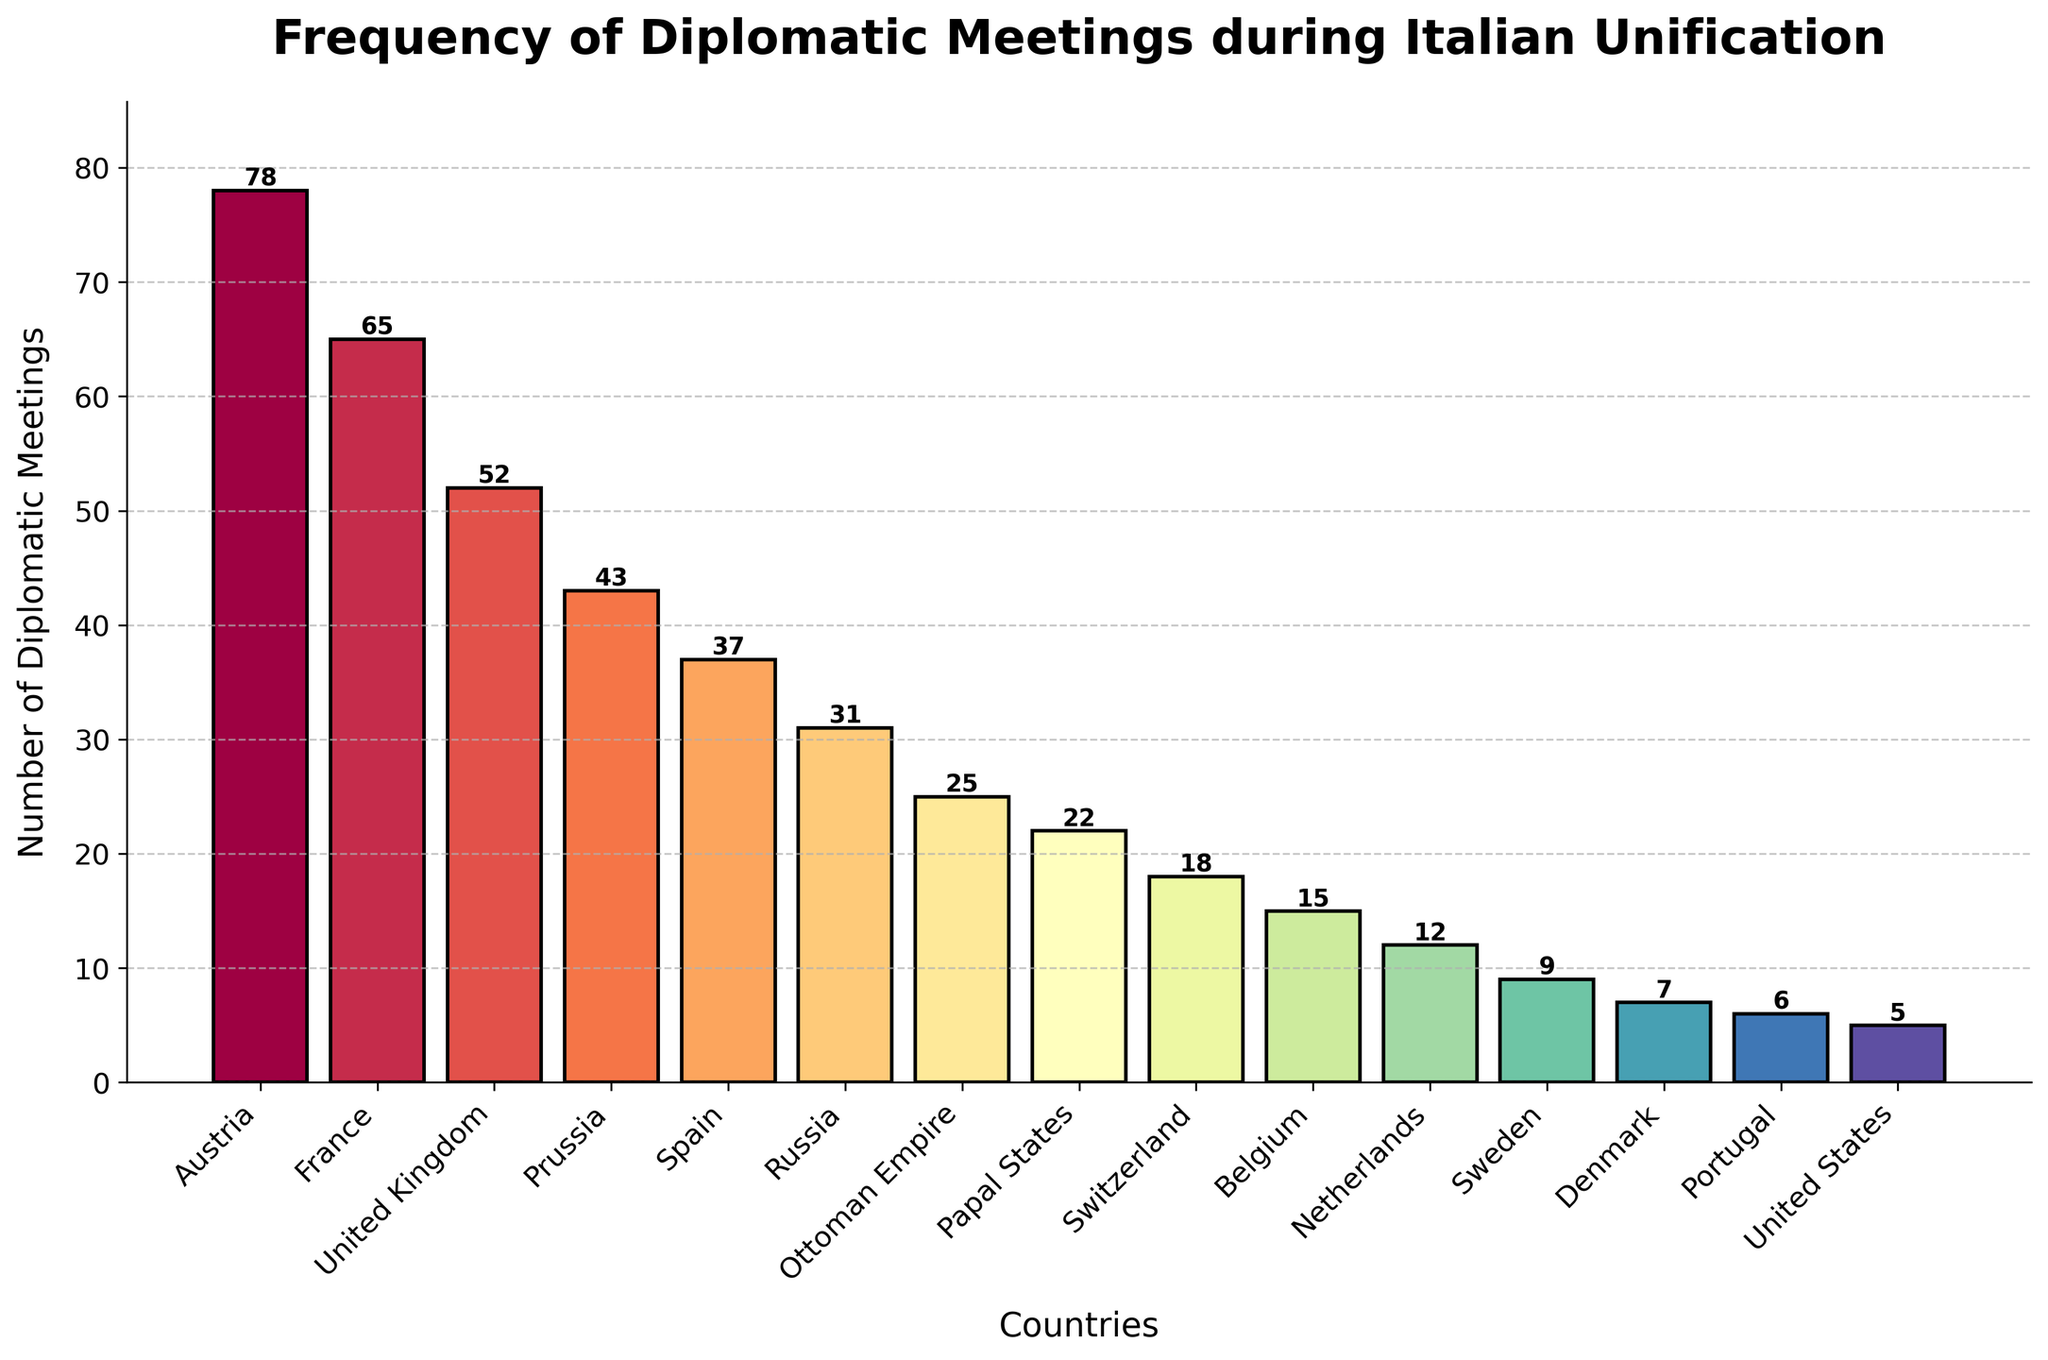Which country had the highest number of diplomatic meetings during the Italian unification? The bar for Austria is the tallest in the figure, indicating it had the highest number of meetings.
Answer: Austria Which country had the fewest diplomatic meetings? The bar for the United States is the shortest in the figure, indicating it had the fewest meetings.
Answer: United States How many more diplomatic meetings did Austria have compared to Prussia? Austria had 78 meetings and Prussia had 43; the difference is calculated as 78 - 43.
Answer: 35 What is the total number of diplomatic meetings with France, United Kingdom, and Prussia combined? Sum the number of meetings for France (65), United Kingdom (52), and Prussia (43). 65 + 52 + 43 = 160.
Answer: 160 Is the number of meetings with Spain greater than with Russia? Compare the heights of the Spain and Russia bars. Spain has 37 meetings and Russia has 31.
Answer: Yes How many more diplomatic meetings did the Papal States have compared to Denmark and the Netherlands combined? Papal States had 22 meetings. Denmark and Netherlands combined had 7 + 12 = 19 meetings. The difference is 22 - 19.
Answer: 3 Which country had a color bar most similar to the Papal States in the gradient spectrum? Visually, the color for Portugal is most similar to that of the Papal States.
Answer: Portugal What is the average number of diplomatic meetings across all countries listed? Sum all meetings (78+65+52+43+37+31+25+22+18+15+12+9+7+6+5 = 425) and divide by the number of countries (15). 425 ÷ 15 = 28.33.
Answer: 28.33 Are there more diplomatic meetings with Switzerland or with Belgium? Compare the heights of the Switzerland and Belgium bars. Switzerland had 18 meetings, and Belgium had 15.
Answer: Switzerland What is the median number of diplomatic meetings across all countries? List the numbers of meetings (5,6,7,9,12,15,18,22,25,31,37,43,52,65,78) and find the middle value. The median is 22.
Answer: 22 